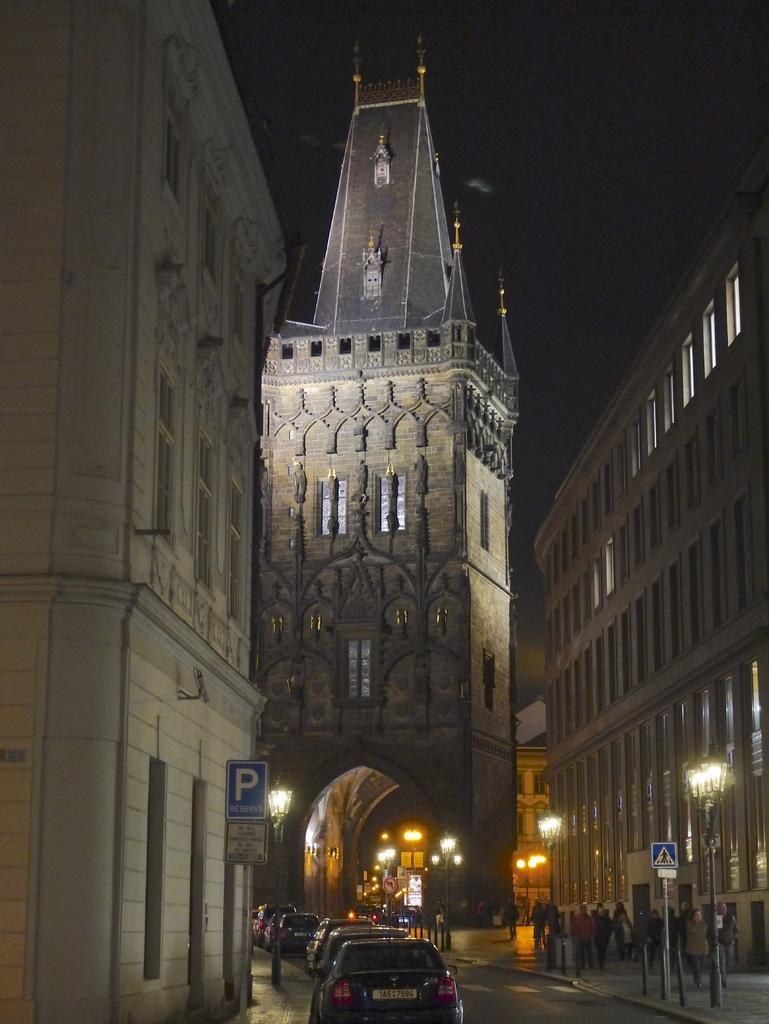Please provide a concise description of this image. In this image I can see few vehicles on the road, I can also see few boards which are in blue color attached to the pole. Background I can see few persons walking and buildings in cream and brown color. 